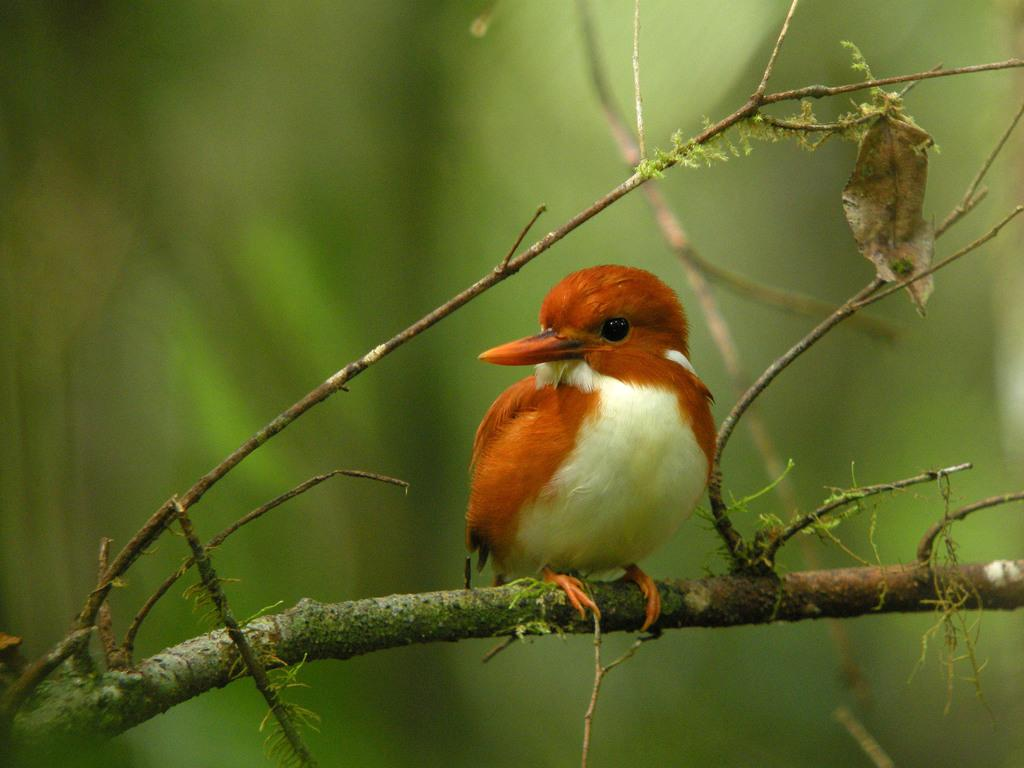What type of animal is in the image? There is a bird in the image. Can you identify the specific species of the bird? The bird is a Madagascan pygmy kingfisher. Where is the bird located in the image? The bird is on a tree. How would you describe the background of the image? The background of the image is blurred. What type of pancake is being prepared in the image? There is no pancake present in the image; it features a Madagascan pygmy kingfisher on a tree. What range of motion does the bird exhibit in the image? The bird's range of motion cannot be determined from the image, as it is a still photograph. 